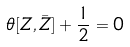<formula> <loc_0><loc_0><loc_500><loc_500>\theta [ Z , \bar { Z } ] + \frac { 1 } { 2 } = 0</formula> 